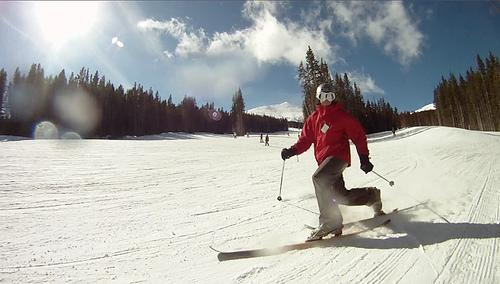What is causing the glare in the image? sun 